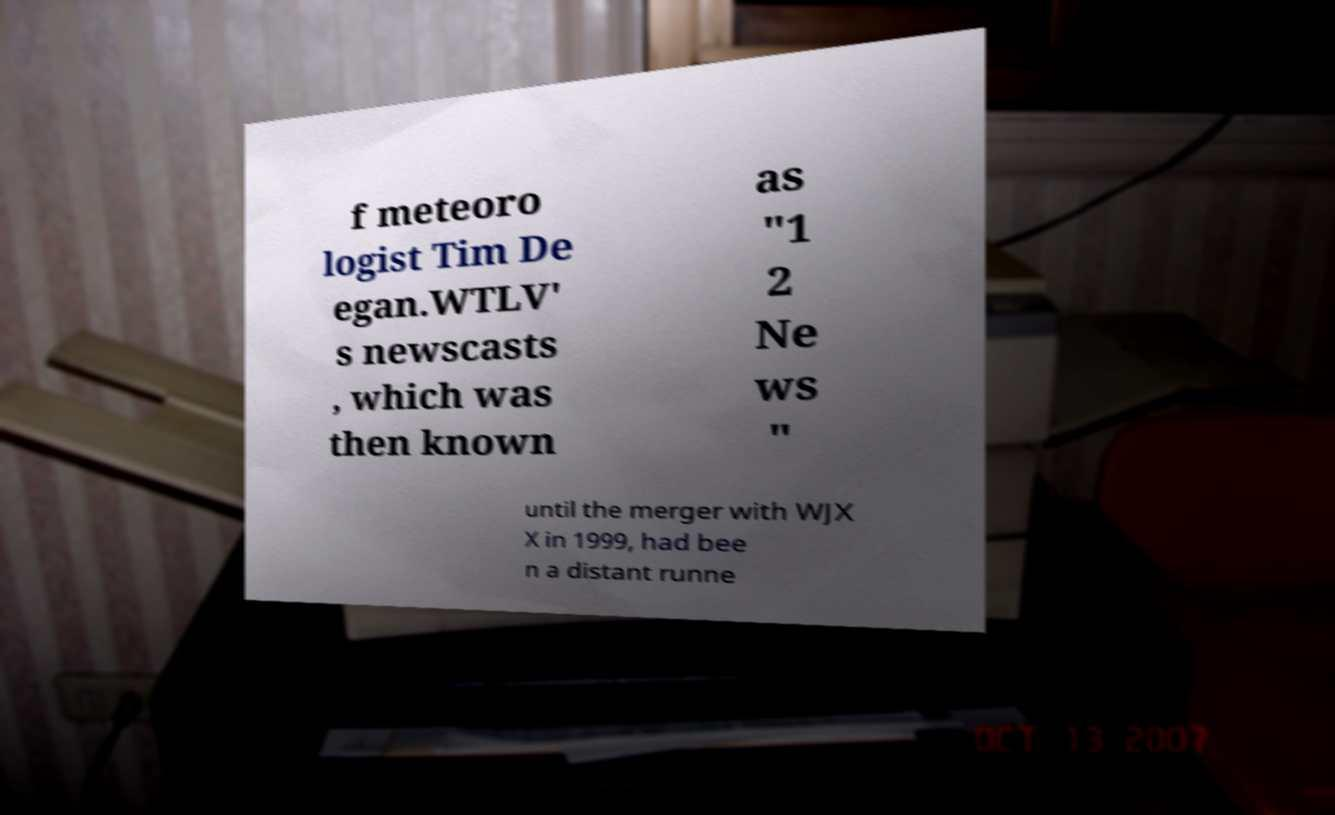Can you read and provide the text displayed in the image?This photo seems to have some interesting text. Can you extract and type it out for me? f meteoro logist Tim De egan.WTLV' s newscasts , which was then known as "1 2 Ne ws " until the merger with WJX X in 1999, had bee n a distant runne 